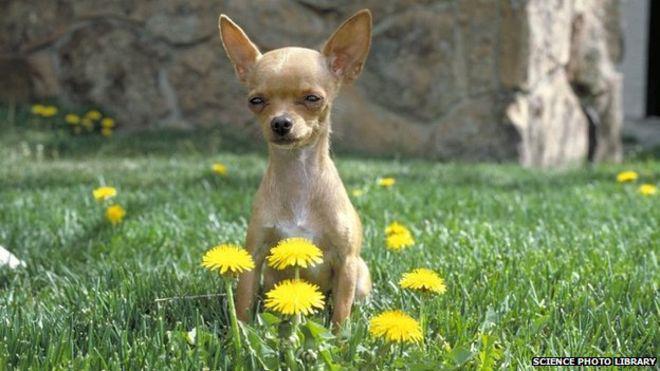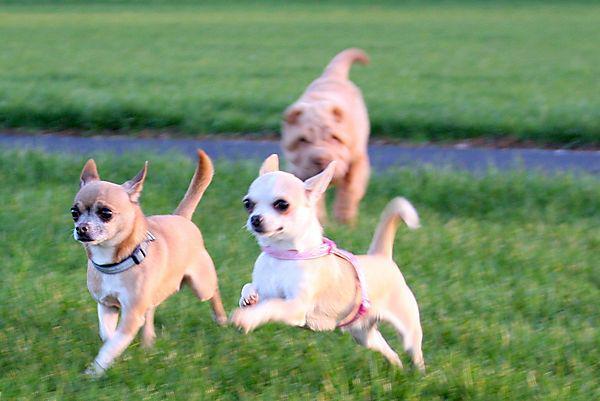The first image is the image on the left, the second image is the image on the right. Evaluate the accuracy of this statement regarding the images: "Exactly four dogs are shown, two in each image, with two in one image wearing outer wear, each in a different color, even though they are inside.". Is it true? Answer yes or no. No. The first image is the image on the left, the second image is the image on the right. For the images displayed, is the sentence "Two chihuahuas in different poses are posed together indoors wearing some type of garment." factually correct? Answer yes or no. No. 